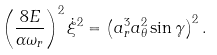Convert formula to latex. <formula><loc_0><loc_0><loc_500><loc_500>\left ( \frac { 8 E } { \alpha \omega _ { r } } \right ) ^ { 2 } \dot { \xi } ^ { 2 } = \left ( a _ { r } ^ { 3 } a _ { \theta } ^ { 2 } \sin \gamma \right ) ^ { 2 } .</formula> 